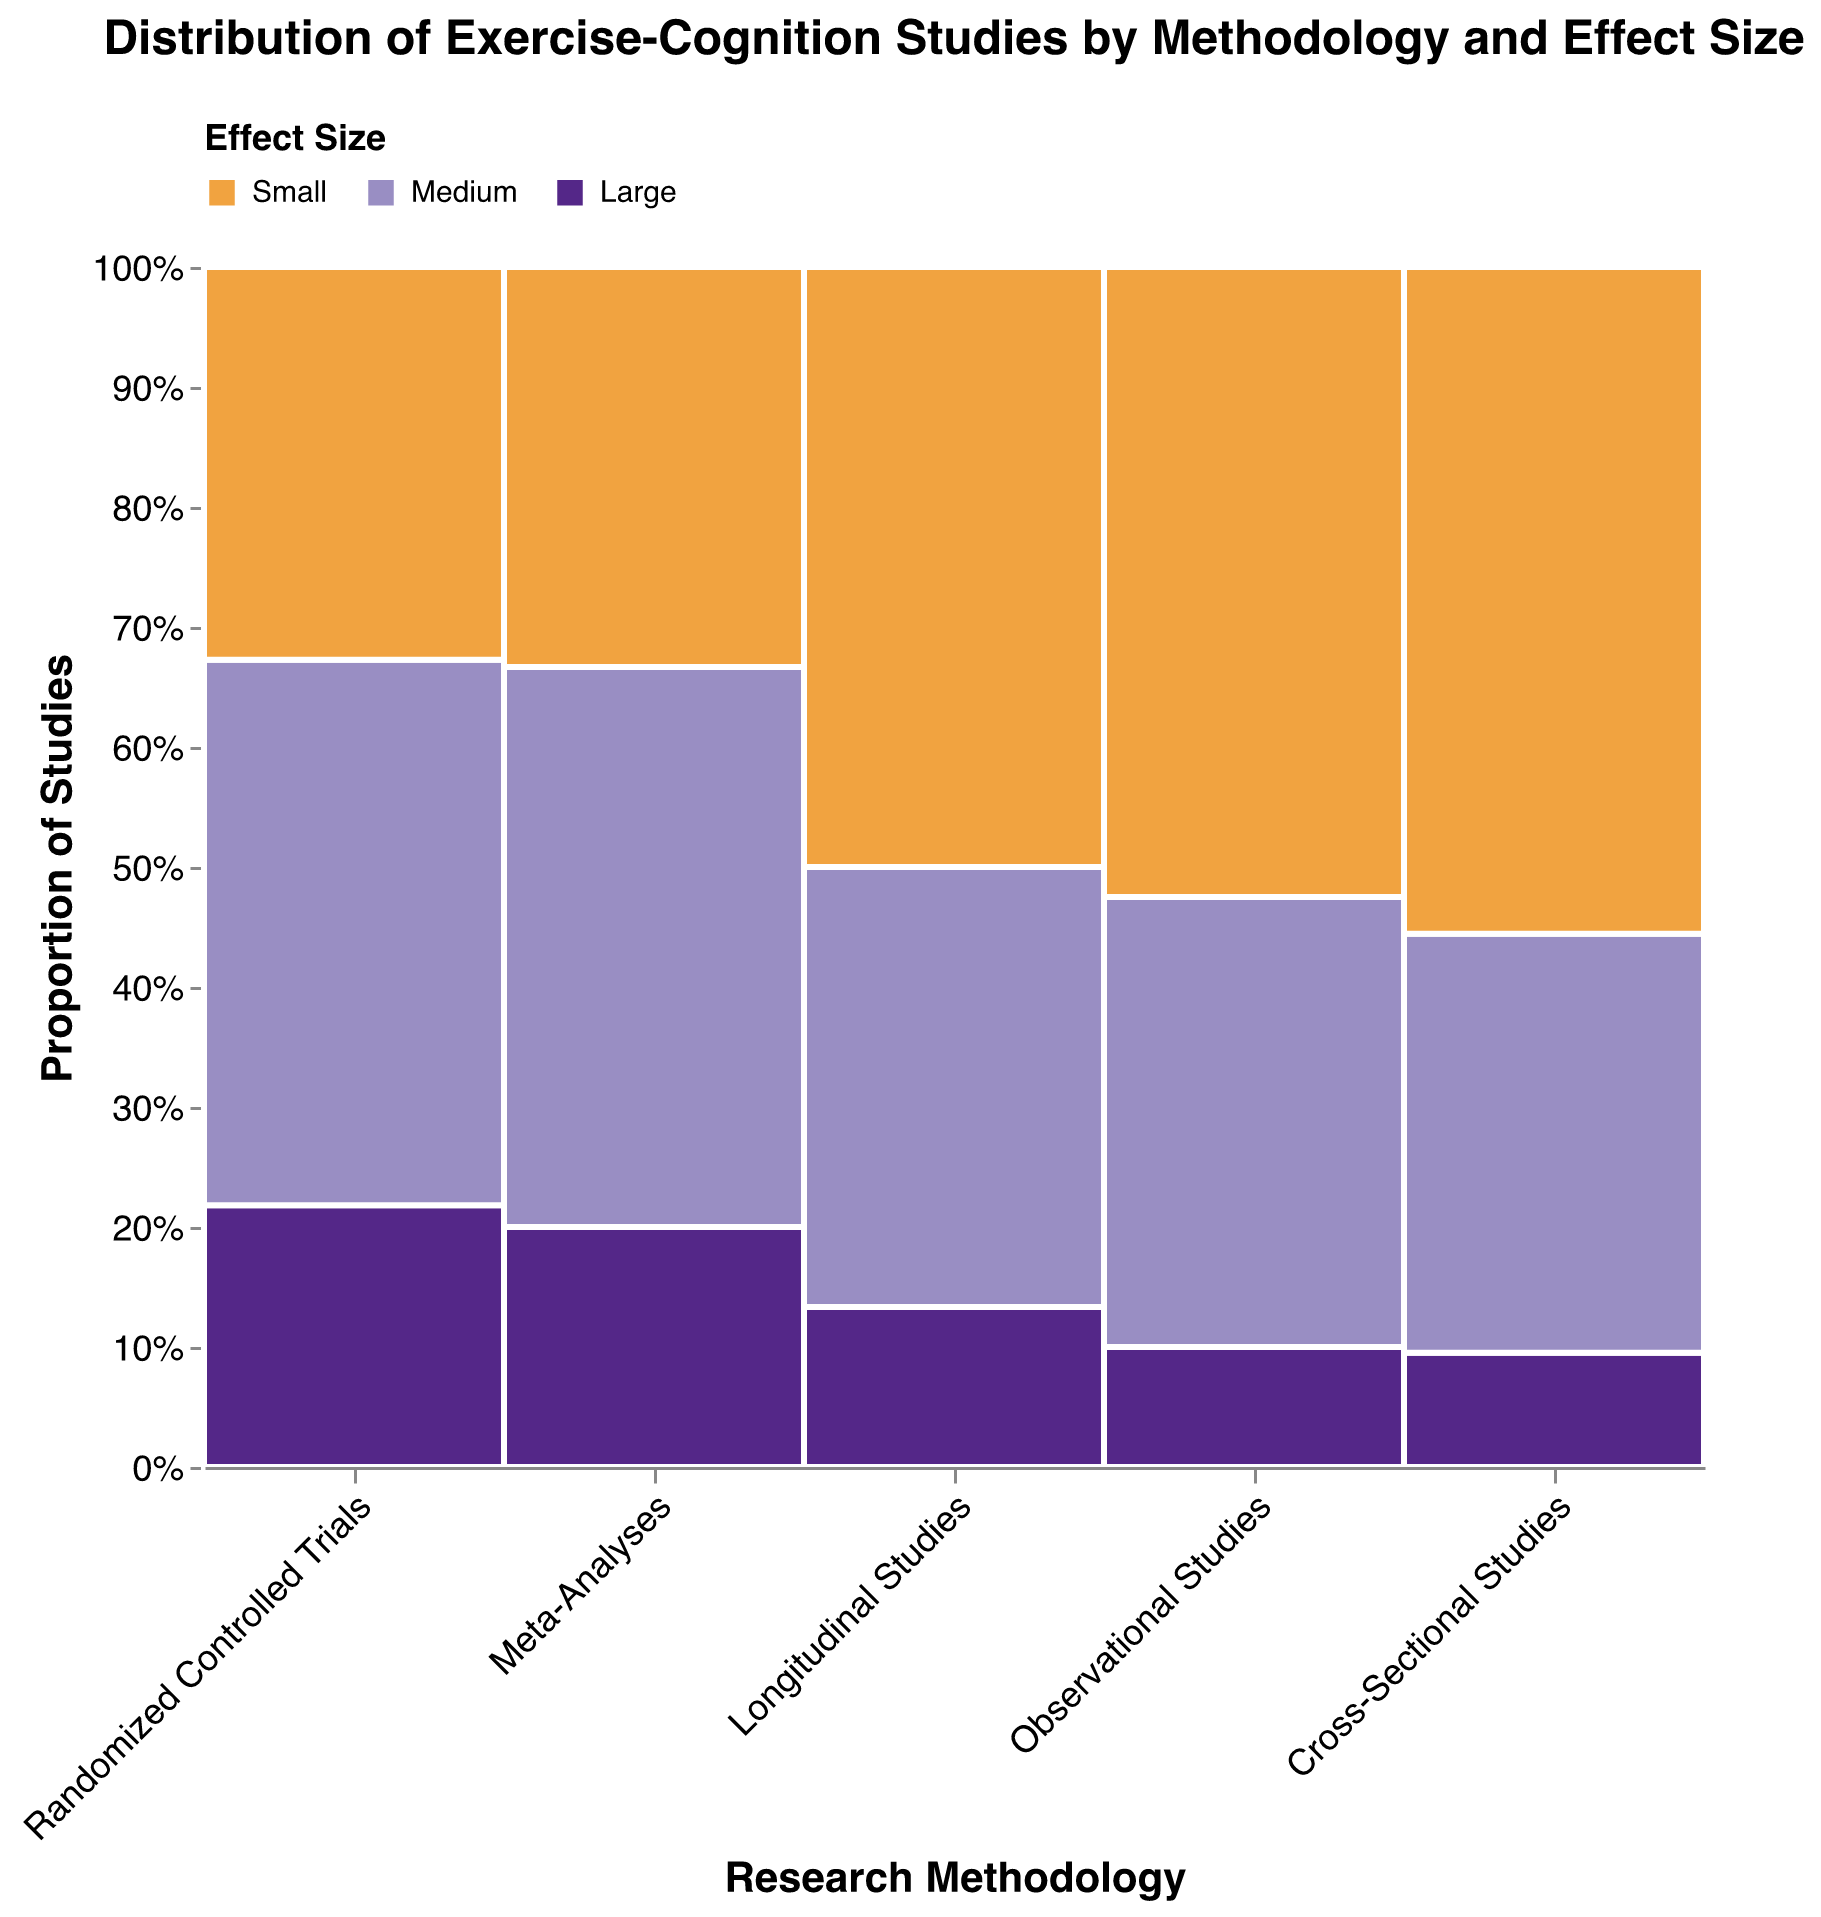What is the proportion of studies with a large effect size in meta-analyses? Locate the "Meta-Analyses" section on the x-axis, and observe the distribution of the colors in this section. Identify the segment corresponding to the color representing "Large". Calculate the height of this segment as a proportion of the entire meta-analyses segment.
Answer: 3/15 = 20% Which research methodology has the highest number of studies reporting small effect sizes? Examine all the sections along the x-axis and identify the subgroup within each that has the color representing "Small". Compare the vertical length of these segments to determine which is the longest.
Answer: Observational Studies How many studies in total report medium effect sizes across all methodologies? Look at each section along the x-axis and identify the number for the "Medium" color within each segment. Sum these numbers: 25 + 30 + 7 + 22 + 11.
Answer: 95 Which research methodology shows the smallest proportion of studies with large effect sizes? For each section on the x-axis, determine the proportion represented by the "Large" color. Compare these proportions to identify the smallest one.
Answer: Meta-Analyses What is the total number of studies employing the Cross-Sectional methodology? Identify the “Cross-Sectional Studies” section on the x-axis and sum the studies: 6 (Large) + 22 (Medium) + 35 (Small).
Answer: 63 Compare the proportion of small effect size studies between randomized controlled trials and longitudinal studies. Which has a higher proportion and by how much? Identify the "Small" colored segments within both "Randomized Controlled Trials" and "Longitudinal Studies" on the x-axis. Calculate each segment's proportion within its respective section and compare them: (18/55) for RCTs, (15/30) for Longitudinal Studies.
Answer: Longitudinal Studies by 0.25 What is the proportion of observational studies in the total number of studies reported in the plot? Sum the total number of studies for all methodologies and calculate the proportion of "Observational Studies": (8 + 30 + 42) / (12 + 25 + 18 + 8 + 30 + 42 + 3 + 7 + 5 + 6 + 22 + 35 + 4 + 11 + 15).
Answer: 80/256 Determine the majority effect size for each research methodology. For each methodology, compare the number of studies for each effect size (Small, Medium, Large) and identify the one with the highest count. Sum the numbers and find the majority for each section: Small for RCTs (25), Small for Observational (42), Medium for Meta-Analyses (7), Small for Cross-Sectional (35), Small for Longitudinal (15).
Answer: Small for RCTs, Small for Observational Studies, Medium for Meta-Analyses, Small for Cross-Sectional Studies, Small for Longitudinal Studies 